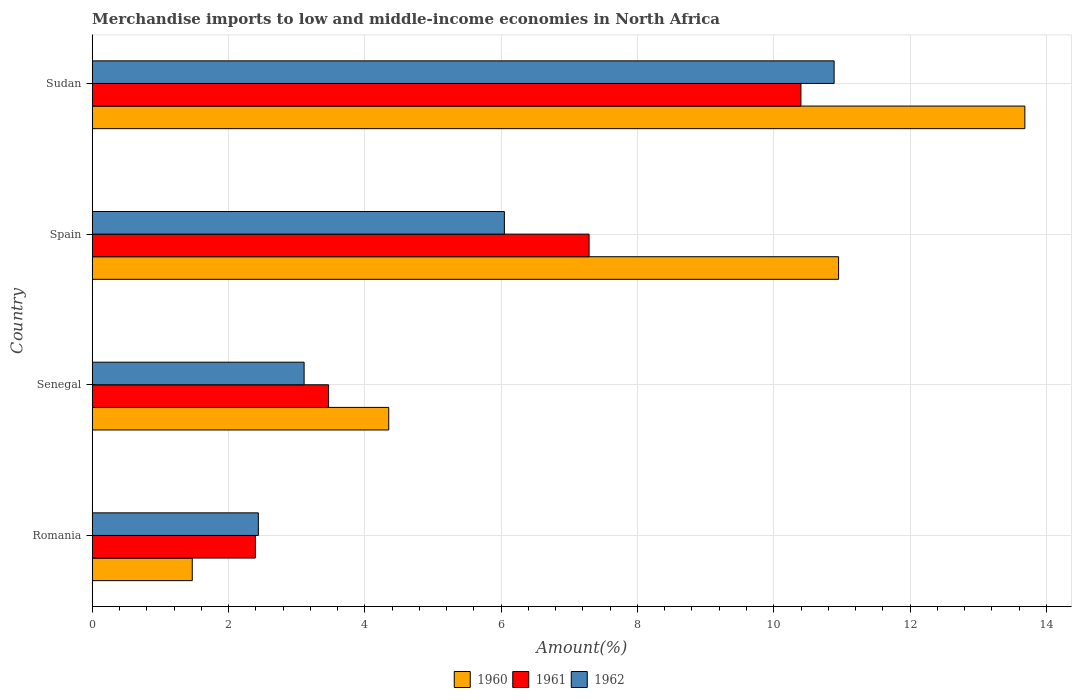How many groups of bars are there?
Offer a terse response. 4. Are the number of bars on each tick of the Y-axis equal?
Your answer should be very brief. Yes. How many bars are there on the 1st tick from the top?
Keep it short and to the point. 3. How many bars are there on the 4th tick from the bottom?
Your answer should be compact. 3. What is the label of the 2nd group of bars from the top?
Give a very brief answer. Spain. In how many cases, is the number of bars for a given country not equal to the number of legend labels?
Offer a terse response. 0. What is the percentage of amount earned from merchandise imports in 1961 in Romania?
Your answer should be compact. 2.39. Across all countries, what is the maximum percentage of amount earned from merchandise imports in 1962?
Keep it short and to the point. 10.89. Across all countries, what is the minimum percentage of amount earned from merchandise imports in 1961?
Provide a short and direct response. 2.39. In which country was the percentage of amount earned from merchandise imports in 1960 maximum?
Offer a terse response. Sudan. In which country was the percentage of amount earned from merchandise imports in 1962 minimum?
Your answer should be compact. Romania. What is the total percentage of amount earned from merchandise imports in 1960 in the graph?
Your answer should be very brief. 30.45. What is the difference between the percentage of amount earned from merchandise imports in 1962 in Senegal and that in Spain?
Make the answer very short. -2.94. What is the difference between the percentage of amount earned from merchandise imports in 1962 in Spain and the percentage of amount earned from merchandise imports in 1961 in Sudan?
Your answer should be compact. -4.35. What is the average percentage of amount earned from merchandise imports in 1962 per country?
Provide a succinct answer. 5.62. What is the difference between the percentage of amount earned from merchandise imports in 1962 and percentage of amount earned from merchandise imports in 1961 in Romania?
Make the answer very short. 0.04. What is the ratio of the percentage of amount earned from merchandise imports in 1962 in Romania to that in Spain?
Provide a short and direct response. 0.4. What is the difference between the highest and the second highest percentage of amount earned from merchandise imports in 1960?
Your answer should be very brief. 2.73. What is the difference between the highest and the lowest percentage of amount earned from merchandise imports in 1962?
Keep it short and to the point. 8.45. In how many countries, is the percentage of amount earned from merchandise imports in 1960 greater than the average percentage of amount earned from merchandise imports in 1960 taken over all countries?
Offer a terse response. 2. Is it the case that in every country, the sum of the percentage of amount earned from merchandise imports in 1962 and percentage of amount earned from merchandise imports in 1960 is greater than the percentage of amount earned from merchandise imports in 1961?
Your answer should be compact. Yes. How many bars are there?
Your response must be concise. 12. How many countries are there in the graph?
Keep it short and to the point. 4. What is the difference between two consecutive major ticks on the X-axis?
Make the answer very short. 2. Are the values on the major ticks of X-axis written in scientific E-notation?
Ensure brevity in your answer.  No. Where does the legend appear in the graph?
Your answer should be compact. Bottom center. How many legend labels are there?
Make the answer very short. 3. How are the legend labels stacked?
Provide a succinct answer. Horizontal. What is the title of the graph?
Your answer should be very brief. Merchandise imports to low and middle-income economies in North Africa. Does "1973" appear as one of the legend labels in the graph?
Ensure brevity in your answer.  No. What is the label or title of the X-axis?
Provide a succinct answer. Amount(%). What is the Amount(%) in 1960 in Romania?
Offer a very short reply. 1.47. What is the Amount(%) of 1961 in Romania?
Ensure brevity in your answer.  2.39. What is the Amount(%) in 1962 in Romania?
Keep it short and to the point. 2.44. What is the Amount(%) of 1960 in Senegal?
Offer a very short reply. 4.35. What is the Amount(%) of 1961 in Senegal?
Offer a terse response. 3.47. What is the Amount(%) of 1962 in Senegal?
Offer a terse response. 3.11. What is the Amount(%) in 1960 in Spain?
Offer a very short reply. 10.95. What is the Amount(%) of 1961 in Spain?
Ensure brevity in your answer.  7.29. What is the Amount(%) of 1962 in Spain?
Ensure brevity in your answer.  6.05. What is the Amount(%) in 1960 in Sudan?
Offer a very short reply. 13.68. What is the Amount(%) of 1961 in Sudan?
Ensure brevity in your answer.  10.4. What is the Amount(%) in 1962 in Sudan?
Offer a terse response. 10.89. Across all countries, what is the maximum Amount(%) in 1960?
Your answer should be compact. 13.68. Across all countries, what is the maximum Amount(%) in 1961?
Provide a succinct answer. 10.4. Across all countries, what is the maximum Amount(%) in 1962?
Give a very brief answer. 10.89. Across all countries, what is the minimum Amount(%) of 1960?
Your answer should be very brief. 1.47. Across all countries, what is the minimum Amount(%) in 1961?
Your answer should be compact. 2.39. Across all countries, what is the minimum Amount(%) in 1962?
Keep it short and to the point. 2.44. What is the total Amount(%) in 1960 in the graph?
Provide a succinct answer. 30.45. What is the total Amount(%) of 1961 in the graph?
Keep it short and to the point. 23.55. What is the total Amount(%) of 1962 in the graph?
Your answer should be very brief. 22.48. What is the difference between the Amount(%) in 1960 in Romania and that in Senegal?
Your answer should be compact. -2.88. What is the difference between the Amount(%) of 1961 in Romania and that in Senegal?
Your response must be concise. -1.07. What is the difference between the Amount(%) of 1962 in Romania and that in Senegal?
Make the answer very short. -0.67. What is the difference between the Amount(%) in 1960 in Romania and that in Spain?
Offer a very short reply. -9.48. What is the difference between the Amount(%) of 1961 in Romania and that in Spain?
Ensure brevity in your answer.  -4.9. What is the difference between the Amount(%) in 1962 in Romania and that in Spain?
Provide a succinct answer. -3.61. What is the difference between the Amount(%) of 1960 in Romania and that in Sudan?
Ensure brevity in your answer.  -12.22. What is the difference between the Amount(%) of 1961 in Romania and that in Sudan?
Ensure brevity in your answer.  -8. What is the difference between the Amount(%) in 1962 in Romania and that in Sudan?
Your answer should be compact. -8.45. What is the difference between the Amount(%) in 1960 in Senegal and that in Spain?
Ensure brevity in your answer.  -6.6. What is the difference between the Amount(%) of 1961 in Senegal and that in Spain?
Your answer should be compact. -3.82. What is the difference between the Amount(%) of 1962 in Senegal and that in Spain?
Offer a very short reply. -2.94. What is the difference between the Amount(%) of 1960 in Senegal and that in Sudan?
Your response must be concise. -9.33. What is the difference between the Amount(%) of 1961 in Senegal and that in Sudan?
Your answer should be compact. -6.93. What is the difference between the Amount(%) in 1962 in Senegal and that in Sudan?
Keep it short and to the point. -7.78. What is the difference between the Amount(%) in 1960 in Spain and that in Sudan?
Give a very brief answer. -2.73. What is the difference between the Amount(%) of 1961 in Spain and that in Sudan?
Your answer should be very brief. -3.11. What is the difference between the Amount(%) of 1962 in Spain and that in Sudan?
Your response must be concise. -4.84. What is the difference between the Amount(%) in 1960 in Romania and the Amount(%) in 1961 in Senegal?
Make the answer very short. -2. What is the difference between the Amount(%) in 1960 in Romania and the Amount(%) in 1962 in Senegal?
Your answer should be very brief. -1.64. What is the difference between the Amount(%) in 1961 in Romania and the Amount(%) in 1962 in Senegal?
Offer a terse response. -0.71. What is the difference between the Amount(%) of 1960 in Romania and the Amount(%) of 1961 in Spain?
Your response must be concise. -5.82. What is the difference between the Amount(%) in 1960 in Romania and the Amount(%) in 1962 in Spain?
Provide a succinct answer. -4.58. What is the difference between the Amount(%) in 1961 in Romania and the Amount(%) in 1962 in Spain?
Give a very brief answer. -3.65. What is the difference between the Amount(%) of 1960 in Romania and the Amount(%) of 1961 in Sudan?
Offer a very short reply. -8.93. What is the difference between the Amount(%) of 1960 in Romania and the Amount(%) of 1962 in Sudan?
Your answer should be compact. -9.42. What is the difference between the Amount(%) of 1961 in Romania and the Amount(%) of 1962 in Sudan?
Give a very brief answer. -8.49. What is the difference between the Amount(%) in 1960 in Senegal and the Amount(%) in 1961 in Spain?
Make the answer very short. -2.94. What is the difference between the Amount(%) of 1960 in Senegal and the Amount(%) of 1962 in Spain?
Ensure brevity in your answer.  -1.7. What is the difference between the Amount(%) in 1961 in Senegal and the Amount(%) in 1962 in Spain?
Offer a terse response. -2.58. What is the difference between the Amount(%) of 1960 in Senegal and the Amount(%) of 1961 in Sudan?
Offer a terse response. -6.05. What is the difference between the Amount(%) of 1960 in Senegal and the Amount(%) of 1962 in Sudan?
Give a very brief answer. -6.54. What is the difference between the Amount(%) in 1961 in Senegal and the Amount(%) in 1962 in Sudan?
Ensure brevity in your answer.  -7.42. What is the difference between the Amount(%) in 1960 in Spain and the Amount(%) in 1961 in Sudan?
Offer a terse response. 0.55. What is the difference between the Amount(%) of 1960 in Spain and the Amount(%) of 1962 in Sudan?
Your answer should be compact. 0.07. What is the difference between the Amount(%) of 1961 in Spain and the Amount(%) of 1962 in Sudan?
Give a very brief answer. -3.6. What is the average Amount(%) in 1960 per country?
Your answer should be compact. 7.61. What is the average Amount(%) of 1961 per country?
Offer a terse response. 5.89. What is the average Amount(%) of 1962 per country?
Provide a succinct answer. 5.62. What is the difference between the Amount(%) of 1960 and Amount(%) of 1961 in Romania?
Provide a succinct answer. -0.93. What is the difference between the Amount(%) of 1960 and Amount(%) of 1962 in Romania?
Your answer should be compact. -0.97. What is the difference between the Amount(%) in 1961 and Amount(%) in 1962 in Romania?
Provide a succinct answer. -0.04. What is the difference between the Amount(%) of 1960 and Amount(%) of 1961 in Senegal?
Keep it short and to the point. 0.88. What is the difference between the Amount(%) of 1960 and Amount(%) of 1962 in Senegal?
Your answer should be very brief. 1.24. What is the difference between the Amount(%) of 1961 and Amount(%) of 1962 in Senegal?
Provide a short and direct response. 0.36. What is the difference between the Amount(%) in 1960 and Amount(%) in 1961 in Spain?
Keep it short and to the point. 3.66. What is the difference between the Amount(%) of 1960 and Amount(%) of 1962 in Spain?
Your answer should be compact. 4.9. What is the difference between the Amount(%) in 1961 and Amount(%) in 1962 in Spain?
Provide a short and direct response. 1.24. What is the difference between the Amount(%) in 1960 and Amount(%) in 1961 in Sudan?
Ensure brevity in your answer.  3.29. What is the difference between the Amount(%) in 1960 and Amount(%) in 1962 in Sudan?
Your answer should be compact. 2.8. What is the difference between the Amount(%) in 1961 and Amount(%) in 1962 in Sudan?
Your answer should be compact. -0.49. What is the ratio of the Amount(%) of 1960 in Romania to that in Senegal?
Your answer should be very brief. 0.34. What is the ratio of the Amount(%) in 1961 in Romania to that in Senegal?
Make the answer very short. 0.69. What is the ratio of the Amount(%) in 1962 in Romania to that in Senegal?
Your response must be concise. 0.78. What is the ratio of the Amount(%) in 1960 in Romania to that in Spain?
Ensure brevity in your answer.  0.13. What is the ratio of the Amount(%) of 1961 in Romania to that in Spain?
Your answer should be compact. 0.33. What is the ratio of the Amount(%) in 1962 in Romania to that in Spain?
Provide a succinct answer. 0.4. What is the ratio of the Amount(%) of 1960 in Romania to that in Sudan?
Offer a very short reply. 0.11. What is the ratio of the Amount(%) in 1961 in Romania to that in Sudan?
Keep it short and to the point. 0.23. What is the ratio of the Amount(%) of 1962 in Romania to that in Sudan?
Offer a terse response. 0.22. What is the ratio of the Amount(%) of 1960 in Senegal to that in Spain?
Your response must be concise. 0.4. What is the ratio of the Amount(%) of 1961 in Senegal to that in Spain?
Give a very brief answer. 0.48. What is the ratio of the Amount(%) of 1962 in Senegal to that in Spain?
Provide a succinct answer. 0.51. What is the ratio of the Amount(%) of 1960 in Senegal to that in Sudan?
Provide a short and direct response. 0.32. What is the ratio of the Amount(%) of 1961 in Senegal to that in Sudan?
Your answer should be very brief. 0.33. What is the ratio of the Amount(%) of 1962 in Senegal to that in Sudan?
Offer a terse response. 0.29. What is the ratio of the Amount(%) of 1960 in Spain to that in Sudan?
Your answer should be very brief. 0.8. What is the ratio of the Amount(%) in 1961 in Spain to that in Sudan?
Your answer should be very brief. 0.7. What is the ratio of the Amount(%) of 1962 in Spain to that in Sudan?
Ensure brevity in your answer.  0.56. What is the difference between the highest and the second highest Amount(%) of 1960?
Your answer should be compact. 2.73. What is the difference between the highest and the second highest Amount(%) in 1961?
Offer a very short reply. 3.11. What is the difference between the highest and the second highest Amount(%) in 1962?
Keep it short and to the point. 4.84. What is the difference between the highest and the lowest Amount(%) of 1960?
Keep it short and to the point. 12.22. What is the difference between the highest and the lowest Amount(%) in 1961?
Make the answer very short. 8. What is the difference between the highest and the lowest Amount(%) in 1962?
Make the answer very short. 8.45. 